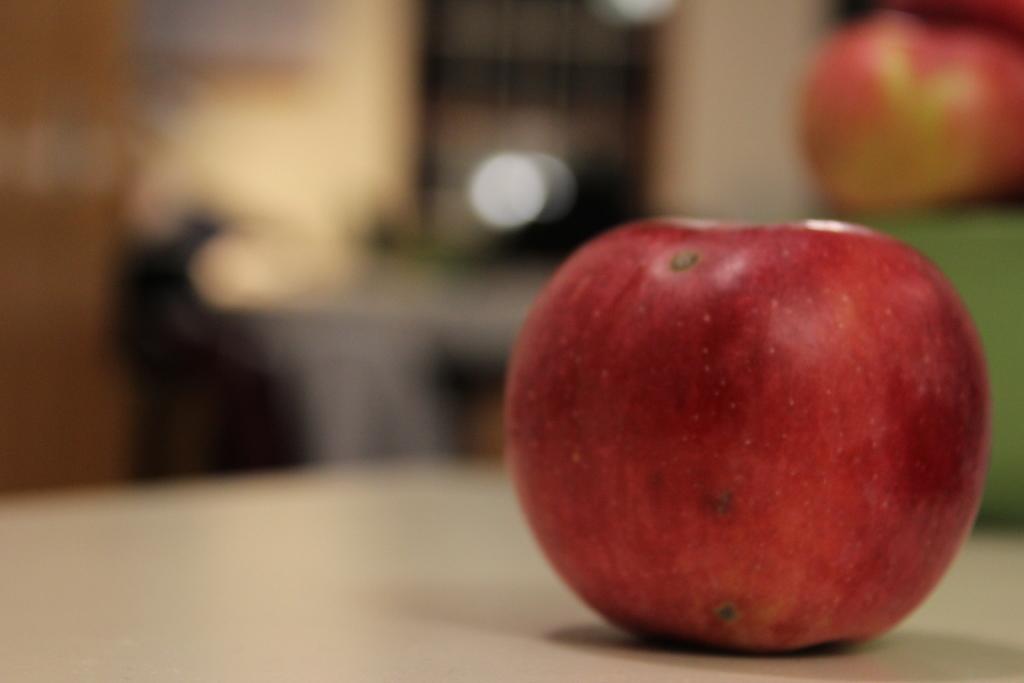In one or two sentences, can you explain what this image depicts? In this image we can see an apple on a surface. The background of the image is blurred. 